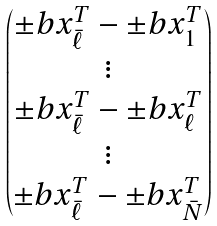Convert formula to latex. <formula><loc_0><loc_0><loc_500><loc_500>\begin{pmatrix} \pm b { x } _ { \bar { \ell } } ^ { T } - \pm b { x } _ { 1 } ^ { T } \\ \vdots \\ \pm b { x } _ { \bar { \ell } } ^ { T } - \pm b { x } _ { \ell } ^ { T } \\ \vdots \\ \pm b { x } _ { \bar { \ell } } ^ { T } - \pm b { x } _ { \bar { N } } ^ { T } \end{pmatrix}</formula> 